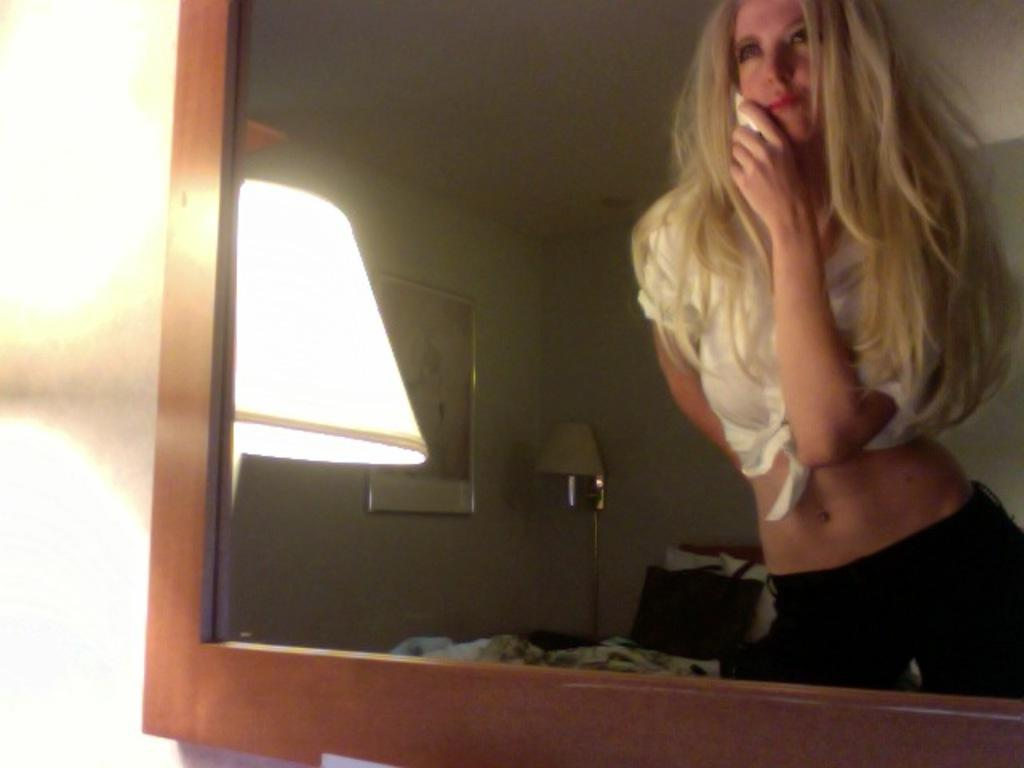What object in the image reflects an image? There is a mirror in the image that reflects a woman. What can be seen in the mirror's reflection? The mirror reflects a woman. What is hanging on the wall in the image? There is a picture on the wall. What type of lighting is present in the image? There are lamps in the image. What type of loaf is being used to improve the acoustics in the image? There is no loaf present in the image, and the acoustics are not mentioned or depicted. 